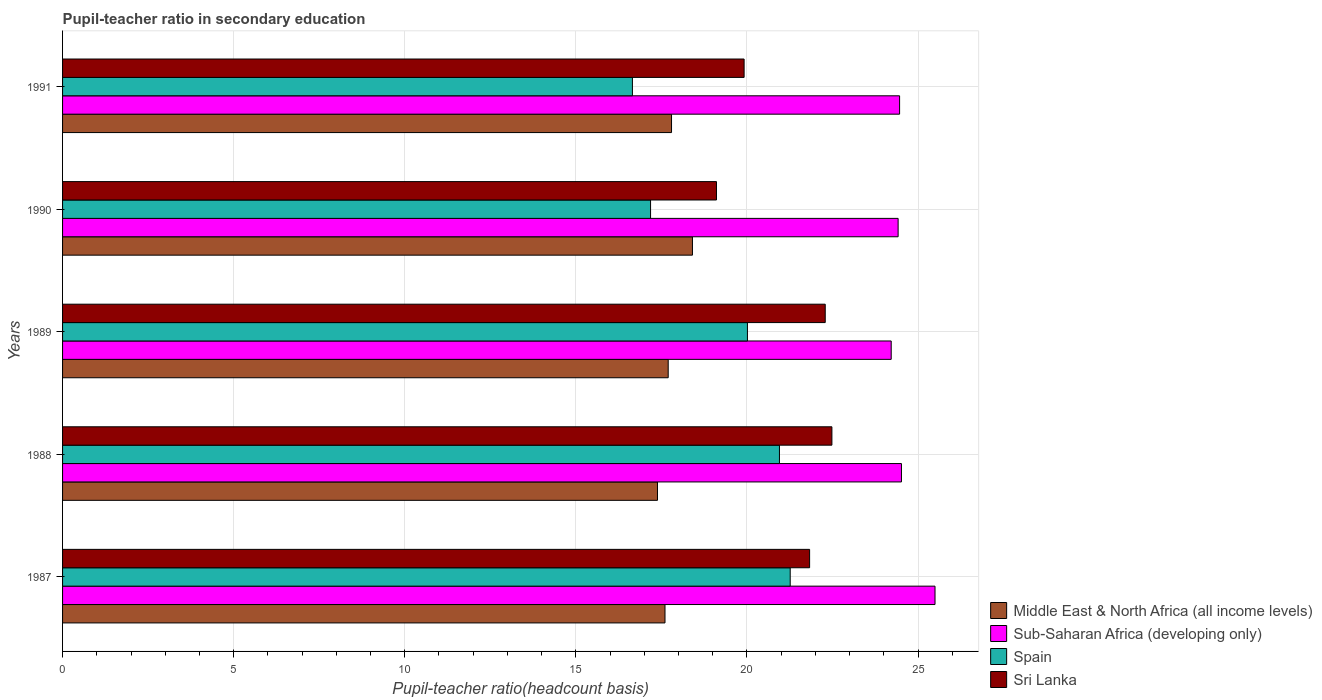How many bars are there on the 3rd tick from the bottom?
Offer a very short reply. 4. In how many cases, is the number of bars for a given year not equal to the number of legend labels?
Provide a short and direct response. 0. What is the pupil-teacher ratio in secondary education in Sri Lanka in 1990?
Make the answer very short. 19.11. Across all years, what is the maximum pupil-teacher ratio in secondary education in Middle East & North Africa (all income levels)?
Keep it short and to the point. 18.41. Across all years, what is the minimum pupil-teacher ratio in secondary education in Sub-Saharan Africa (developing only)?
Give a very brief answer. 24.22. What is the total pupil-teacher ratio in secondary education in Sub-Saharan Africa (developing only) in the graph?
Your answer should be very brief. 123.1. What is the difference between the pupil-teacher ratio in secondary education in Sub-Saharan Africa (developing only) in 1987 and that in 1990?
Ensure brevity in your answer.  1.08. What is the difference between the pupil-teacher ratio in secondary education in Sri Lanka in 1990 and the pupil-teacher ratio in secondary education in Spain in 1989?
Provide a short and direct response. -0.9. What is the average pupil-teacher ratio in secondary education in Sub-Saharan Africa (developing only) per year?
Provide a succinct answer. 24.62. In the year 1988, what is the difference between the pupil-teacher ratio in secondary education in Sub-Saharan Africa (developing only) and pupil-teacher ratio in secondary education in Middle East & North Africa (all income levels)?
Keep it short and to the point. 7.13. In how many years, is the pupil-teacher ratio in secondary education in Sub-Saharan Africa (developing only) greater than 8 ?
Ensure brevity in your answer.  5. What is the ratio of the pupil-teacher ratio in secondary education in Sri Lanka in 1990 to that in 1991?
Your answer should be compact. 0.96. Is the difference between the pupil-teacher ratio in secondary education in Sub-Saharan Africa (developing only) in 1987 and 1991 greater than the difference between the pupil-teacher ratio in secondary education in Middle East & North Africa (all income levels) in 1987 and 1991?
Offer a terse response. Yes. What is the difference between the highest and the second highest pupil-teacher ratio in secondary education in Spain?
Provide a succinct answer. 0.31. What is the difference between the highest and the lowest pupil-teacher ratio in secondary education in Spain?
Offer a very short reply. 4.61. Is the sum of the pupil-teacher ratio in secondary education in Middle East & North Africa (all income levels) in 1987 and 1990 greater than the maximum pupil-teacher ratio in secondary education in Sub-Saharan Africa (developing only) across all years?
Give a very brief answer. Yes. Is it the case that in every year, the sum of the pupil-teacher ratio in secondary education in Sri Lanka and pupil-teacher ratio in secondary education in Sub-Saharan Africa (developing only) is greater than the sum of pupil-teacher ratio in secondary education in Spain and pupil-teacher ratio in secondary education in Middle East & North Africa (all income levels)?
Provide a succinct answer. Yes. What does the 2nd bar from the top in 1988 represents?
Ensure brevity in your answer.  Spain. What does the 3rd bar from the bottom in 1991 represents?
Your answer should be compact. Spain. Is it the case that in every year, the sum of the pupil-teacher ratio in secondary education in Sri Lanka and pupil-teacher ratio in secondary education in Middle East & North Africa (all income levels) is greater than the pupil-teacher ratio in secondary education in Sub-Saharan Africa (developing only)?
Your answer should be very brief. Yes. How many bars are there?
Keep it short and to the point. 20. Are all the bars in the graph horizontal?
Provide a succinct answer. Yes. How many years are there in the graph?
Your response must be concise. 5. What is the difference between two consecutive major ticks on the X-axis?
Provide a succinct answer. 5. Where does the legend appear in the graph?
Your answer should be compact. Bottom right. How many legend labels are there?
Provide a succinct answer. 4. How are the legend labels stacked?
Keep it short and to the point. Vertical. What is the title of the graph?
Your answer should be compact. Pupil-teacher ratio in secondary education. What is the label or title of the X-axis?
Make the answer very short. Pupil-teacher ratio(headcount basis). What is the Pupil-teacher ratio(headcount basis) in Middle East & North Africa (all income levels) in 1987?
Offer a terse response. 17.61. What is the Pupil-teacher ratio(headcount basis) of Sub-Saharan Africa (developing only) in 1987?
Give a very brief answer. 25.5. What is the Pupil-teacher ratio(headcount basis) of Spain in 1987?
Your answer should be very brief. 21.26. What is the Pupil-teacher ratio(headcount basis) in Sri Lanka in 1987?
Offer a terse response. 21.83. What is the Pupil-teacher ratio(headcount basis) of Middle East & North Africa (all income levels) in 1988?
Your response must be concise. 17.39. What is the Pupil-teacher ratio(headcount basis) in Sub-Saharan Africa (developing only) in 1988?
Keep it short and to the point. 24.51. What is the Pupil-teacher ratio(headcount basis) of Spain in 1988?
Offer a terse response. 20.95. What is the Pupil-teacher ratio(headcount basis) in Sri Lanka in 1988?
Your answer should be compact. 22.48. What is the Pupil-teacher ratio(headcount basis) in Middle East & North Africa (all income levels) in 1989?
Offer a very short reply. 17.7. What is the Pupil-teacher ratio(headcount basis) in Sub-Saharan Africa (developing only) in 1989?
Ensure brevity in your answer.  24.22. What is the Pupil-teacher ratio(headcount basis) of Spain in 1989?
Your response must be concise. 20.01. What is the Pupil-teacher ratio(headcount basis) of Sri Lanka in 1989?
Provide a succinct answer. 22.29. What is the Pupil-teacher ratio(headcount basis) of Middle East & North Africa (all income levels) in 1990?
Keep it short and to the point. 18.41. What is the Pupil-teacher ratio(headcount basis) of Sub-Saharan Africa (developing only) in 1990?
Offer a terse response. 24.42. What is the Pupil-teacher ratio(headcount basis) in Spain in 1990?
Your response must be concise. 17.18. What is the Pupil-teacher ratio(headcount basis) of Sri Lanka in 1990?
Give a very brief answer. 19.11. What is the Pupil-teacher ratio(headcount basis) in Middle East & North Africa (all income levels) in 1991?
Give a very brief answer. 17.8. What is the Pupil-teacher ratio(headcount basis) of Sub-Saharan Africa (developing only) in 1991?
Make the answer very short. 24.46. What is the Pupil-teacher ratio(headcount basis) in Spain in 1991?
Your answer should be compact. 16.65. What is the Pupil-teacher ratio(headcount basis) of Sri Lanka in 1991?
Your response must be concise. 19.92. Across all years, what is the maximum Pupil-teacher ratio(headcount basis) in Middle East & North Africa (all income levels)?
Offer a terse response. 18.41. Across all years, what is the maximum Pupil-teacher ratio(headcount basis) in Sub-Saharan Africa (developing only)?
Offer a terse response. 25.5. Across all years, what is the maximum Pupil-teacher ratio(headcount basis) of Spain?
Make the answer very short. 21.26. Across all years, what is the maximum Pupil-teacher ratio(headcount basis) in Sri Lanka?
Keep it short and to the point. 22.48. Across all years, what is the minimum Pupil-teacher ratio(headcount basis) in Middle East & North Africa (all income levels)?
Provide a succinct answer. 17.39. Across all years, what is the minimum Pupil-teacher ratio(headcount basis) of Sub-Saharan Africa (developing only)?
Offer a terse response. 24.22. Across all years, what is the minimum Pupil-teacher ratio(headcount basis) of Spain?
Ensure brevity in your answer.  16.65. Across all years, what is the minimum Pupil-teacher ratio(headcount basis) in Sri Lanka?
Your answer should be very brief. 19.11. What is the total Pupil-teacher ratio(headcount basis) in Middle East & North Africa (all income levels) in the graph?
Your response must be concise. 88.89. What is the total Pupil-teacher ratio(headcount basis) of Sub-Saharan Africa (developing only) in the graph?
Offer a very short reply. 123.1. What is the total Pupil-teacher ratio(headcount basis) in Spain in the graph?
Ensure brevity in your answer.  96.06. What is the total Pupil-teacher ratio(headcount basis) in Sri Lanka in the graph?
Ensure brevity in your answer.  105.63. What is the difference between the Pupil-teacher ratio(headcount basis) in Middle East & North Africa (all income levels) in 1987 and that in 1988?
Ensure brevity in your answer.  0.22. What is the difference between the Pupil-teacher ratio(headcount basis) of Sub-Saharan Africa (developing only) in 1987 and that in 1988?
Make the answer very short. 0.98. What is the difference between the Pupil-teacher ratio(headcount basis) in Spain in 1987 and that in 1988?
Ensure brevity in your answer.  0.31. What is the difference between the Pupil-teacher ratio(headcount basis) in Sri Lanka in 1987 and that in 1988?
Offer a terse response. -0.65. What is the difference between the Pupil-teacher ratio(headcount basis) of Middle East & North Africa (all income levels) in 1987 and that in 1989?
Keep it short and to the point. -0.09. What is the difference between the Pupil-teacher ratio(headcount basis) in Sub-Saharan Africa (developing only) in 1987 and that in 1989?
Your answer should be compact. 1.28. What is the difference between the Pupil-teacher ratio(headcount basis) in Spain in 1987 and that in 1989?
Give a very brief answer. 1.25. What is the difference between the Pupil-teacher ratio(headcount basis) of Sri Lanka in 1987 and that in 1989?
Provide a short and direct response. -0.46. What is the difference between the Pupil-teacher ratio(headcount basis) of Middle East & North Africa (all income levels) in 1987 and that in 1990?
Offer a very short reply. -0.8. What is the difference between the Pupil-teacher ratio(headcount basis) of Sub-Saharan Africa (developing only) in 1987 and that in 1990?
Ensure brevity in your answer.  1.08. What is the difference between the Pupil-teacher ratio(headcount basis) in Spain in 1987 and that in 1990?
Provide a succinct answer. 4.08. What is the difference between the Pupil-teacher ratio(headcount basis) in Sri Lanka in 1987 and that in 1990?
Make the answer very short. 2.72. What is the difference between the Pupil-teacher ratio(headcount basis) of Middle East & North Africa (all income levels) in 1987 and that in 1991?
Your answer should be compact. -0.19. What is the difference between the Pupil-teacher ratio(headcount basis) in Sub-Saharan Africa (developing only) in 1987 and that in 1991?
Offer a terse response. 1.03. What is the difference between the Pupil-teacher ratio(headcount basis) of Spain in 1987 and that in 1991?
Make the answer very short. 4.61. What is the difference between the Pupil-teacher ratio(headcount basis) in Sri Lanka in 1987 and that in 1991?
Ensure brevity in your answer.  1.91. What is the difference between the Pupil-teacher ratio(headcount basis) in Middle East & North Africa (all income levels) in 1988 and that in 1989?
Give a very brief answer. -0.31. What is the difference between the Pupil-teacher ratio(headcount basis) of Sub-Saharan Africa (developing only) in 1988 and that in 1989?
Offer a terse response. 0.3. What is the difference between the Pupil-teacher ratio(headcount basis) in Spain in 1988 and that in 1989?
Your answer should be very brief. 0.94. What is the difference between the Pupil-teacher ratio(headcount basis) of Sri Lanka in 1988 and that in 1989?
Your answer should be very brief. 0.2. What is the difference between the Pupil-teacher ratio(headcount basis) of Middle East & North Africa (all income levels) in 1988 and that in 1990?
Keep it short and to the point. -1.02. What is the difference between the Pupil-teacher ratio(headcount basis) of Sub-Saharan Africa (developing only) in 1988 and that in 1990?
Give a very brief answer. 0.1. What is the difference between the Pupil-teacher ratio(headcount basis) in Spain in 1988 and that in 1990?
Offer a terse response. 3.77. What is the difference between the Pupil-teacher ratio(headcount basis) in Sri Lanka in 1988 and that in 1990?
Provide a succinct answer. 3.37. What is the difference between the Pupil-teacher ratio(headcount basis) of Middle East & North Africa (all income levels) in 1988 and that in 1991?
Keep it short and to the point. -0.41. What is the difference between the Pupil-teacher ratio(headcount basis) of Sub-Saharan Africa (developing only) in 1988 and that in 1991?
Keep it short and to the point. 0.05. What is the difference between the Pupil-teacher ratio(headcount basis) in Spain in 1988 and that in 1991?
Make the answer very short. 4.3. What is the difference between the Pupil-teacher ratio(headcount basis) of Sri Lanka in 1988 and that in 1991?
Provide a short and direct response. 2.57. What is the difference between the Pupil-teacher ratio(headcount basis) of Middle East & North Africa (all income levels) in 1989 and that in 1990?
Ensure brevity in your answer.  -0.71. What is the difference between the Pupil-teacher ratio(headcount basis) of Sub-Saharan Africa (developing only) in 1989 and that in 1990?
Ensure brevity in your answer.  -0.2. What is the difference between the Pupil-teacher ratio(headcount basis) in Spain in 1989 and that in 1990?
Provide a succinct answer. 2.83. What is the difference between the Pupil-teacher ratio(headcount basis) in Sri Lanka in 1989 and that in 1990?
Keep it short and to the point. 3.18. What is the difference between the Pupil-teacher ratio(headcount basis) in Middle East & North Africa (all income levels) in 1989 and that in 1991?
Keep it short and to the point. -0.1. What is the difference between the Pupil-teacher ratio(headcount basis) in Sub-Saharan Africa (developing only) in 1989 and that in 1991?
Provide a succinct answer. -0.25. What is the difference between the Pupil-teacher ratio(headcount basis) of Spain in 1989 and that in 1991?
Give a very brief answer. 3.36. What is the difference between the Pupil-teacher ratio(headcount basis) of Sri Lanka in 1989 and that in 1991?
Ensure brevity in your answer.  2.37. What is the difference between the Pupil-teacher ratio(headcount basis) of Middle East & North Africa (all income levels) in 1990 and that in 1991?
Provide a short and direct response. 0.61. What is the difference between the Pupil-teacher ratio(headcount basis) of Sub-Saharan Africa (developing only) in 1990 and that in 1991?
Keep it short and to the point. -0.04. What is the difference between the Pupil-teacher ratio(headcount basis) in Spain in 1990 and that in 1991?
Provide a short and direct response. 0.53. What is the difference between the Pupil-teacher ratio(headcount basis) in Sri Lanka in 1990 and that in 1991?
Your answer should be compact. -0.81. What is the difference between the Pupil-teacher ratio(headcount basis) in Middle East & North Africa (all income levels) in 1987 and the Pupil-teacher ratio(headcount basis) in Sub-Saharan Africa (developing only) in 1988?
Provide a short and direct response. -6.91. What is the difference between the Pupil-teacher ratio(headcount basis) of Middle East & North Africa (all income levels) in 1987 and the Pupil-teacher ratio(headcount basis) of Spain in 1988?
Keep it short and to the point. -3.34. What is the difference between the Pupil-teacher ratio(headcount basis) in Middle East & North Africa (all income levels) in 1987 and the Pupil-teacher ratio(headcount basis) in Sri Lanka in 1988?
Offer a very short reply. -4.88. What is the difference between the Pupil-teacher ratio(headcount basis) of Sub-Saharan Africa (developing only) in 1987 and the Pupil-teacher ratio(headcount basis) of Spain in 1988?
Provide a short and direct response. 4.55. What is the difference between the Pupil-teacher ratio(headcount basis) in Sub-Saharan Africa (developing only) in 1987 and the Pupil-teacher ratio(headcount basis) in Sri Lanka in 1988?
Provide a succinct answer. 3.01. What is the difference between the Pupil-teacher ratio(headcount basis) in Spain in 1987 and the Pupil-teacher ratio(headcount basis) in Sri Lanka in 1988?
Provide a succinct answer. -1.22. What is the difference between the Pupil-teacher ratio(headcount basis) in Middle East & North Africa (all income levels) in 1987 and the Pupil-teacher ratio(headcount basis) in Sub-Saharan Africa (developing only) in 1989?
Keep it short and to the point. -6.61. What is the difference between the Pupil-teacher ratio(headcount basis) of Middle East & North Africa (all income levels) in 1987 and the Pupil-teacher ratio(headcount basis) of Spain in 1989?
Your answer should be very brief. -2.41. What is the difference between the Pupil-teacher ratio(headcount basis) in Middle East & North Africa (all income levels) in 1987 and the Pupil-teacher ratio(headcount basis) in Sri Lanka in 1989?
Provide a short and direct response. -4.68. What is the difference between the Pupil-teacher ratio(headcount basis) in Sub-Saharan Africa (developing only) in 1987 and the Pupil-teacher ratio(headcount basis) in Spain in 1989?
Provide a short and direct response. 5.48. What is the difference between the Pupil-teacher ratio(headcount basis) in Sub-Saharan Africa (developing only) in 1987 and the Pupil-teacher ratio(headcount basis) in Sri Lanka in 1989?
Your answer should be very brief. 3.21. What is the difference between the Pupil-teacher ratio(headcount basis) of Spain in 1987 and the Pupil-teacher ratio(headcount basis) of Sri Lanka in 1989?
Your answer should be very brief. -1.02. What is the difference between the Pupil-teacher ratio(headcount basis) in Middle East & North Africa (all income levels) in 1987 and the Pupil-teacher ratio(headcount basis) in Sub-Saharan Africa (developing only) in 1990?
Provide a short and direct response. -6.81. What is the difference between the Pupil-teacher ratio(headcount basis) of Middle East & North Africa (all income levels) in 1987 and the Pupil-teacher ratio(headcount basis) of Spain in 1990?
Provide a succinct answer. 0.42. What is the difference between the Pupil-teacher ratio(headcount basis) in Middle East & North Africa (all income levels) in 1987 and the Pupil-teacher ratio(headcount basis) in Sri Lanka in 1990?
Provide a short and direct response. -1.5. What is the difference between the Pupil-teacher ratio(headcount basis) of Sub-Saharan Africa (developing only) in 1987 and the Pupil-teacher ratio(headcount basis) of Spain in 1990?
Keep it short and to the point. 8.31. What is the difference between the Pupil-teacher ratio(headcount basis) of Sub-Saharan Africa (developing only) in 1987 and the Pupil-teacher ratio(headcount basis) of Sri Lanka in 1990?
Your response must be concise. 6.39. What is the difference between the Pupil-teacher ratio(headcount basis) in Spain in 1987 and the Pupil-teacher ratio(headcount basis) in Sri Lanka in 1990?
Your response must be concise. 2.15. What is the difference between the Pupil-teacher ratio(headcount basis) in Middle East & North Africa (all income levels) in 1987 and the Pupil-teacher ratio(headcount basis) in Sub-Saharan Africa (developing only) in 1991?
Your response must be concise. -6.86. What is the difference between the Pupil-teacher ratio(headcount basis) in Middle East & North Africa (all income levels) in 1987 and the Pupil-teacher ratio(headcount basis) in Spain in 1991?
Your answer should be compact. 0.95. What is the difference between the Pupil-teacher ratio(headcount basis) in Middle East & North Africa (all income levels) in 1987 and the Pupil-teacher ratio(headcount basis) in Sri Lanka in 1991?
Your response must be concise. -2.31. What is the difference between the Pupil-teacher ratio(headcount basis) in Sub-Saharan Africa (developing only) in 1987 and the Pupil-teacher ratio(headcount basis) in Spain in 1991?
Your answer should be very brief. 8.84. What is the difference between the Pupil-teacher ratio(headcount basis) in Sub-Saharan Africa (developing only) in 1987 and the Pupil-teacher ratio(headcount basis) in Sri Lanka in 1991?
Your response must be concise. 5.58. What is the difference between the Pupil-teacher ratio(headcount basis) in Spain in 1987 and the Pupil-teacher ratio(headcount basis) in Sri Lanka in 1991?
Ensure brevity in your answer.  1.35. What is the difference between the Pupil-teacher ratio(headcount basis) in Middle East & North Africa (all income levels) in 1988 and the Pupil-teacher ratio(headcount basis) in Sub-Saharan Africa (developing only) in 1989?
Your response must be concise. -6.83. What is the difference between the Pupil-teacher ratio(headcount basis) in Middle East & North Africa (all income levels) in 1988 and the Pupil-teacher ratio(headcount basis) in Spain in 1989?
Ensure brevity in your answer.  -2.63. What is the difference between the Pupil-teacher ratio(headcount basis) of Middle East & North Africa (all income levels) in 1988 and the Pupil-teacher ratio(headcount basis) of Sri Lanka in 1989?
Offer a terse response. -4.9. What is the difference between the Pupil-teacher ratio(headcount basis) in Sub-Saharan Africa (developing only) in 1988 and the Pupil-teacher ratio(headcount basis) in Spain in 1989?
Your response must be concise. 4.5. What is the difference between the Pupil-teacher ratio(headcount basis) of Sub-Saharan Africa (developing only) in 1988 and the Pupil-teacher ratio(headcount basis) of Sri Lanka in 1989?
Offer a very short reply. 2.23. What is the difference between the Pupil-teacher ratio(headcount basis) in Spain in 1988 and the Pupil-teacher ratio(headcount basis) in Sri Lanka in 1989?
Ensure brevity in your answer.  -1.34. What is the difference between the Pupil-teacher ratio(headcount basis) in Middle East & North Africa (all income levels) in 1988 and the Pupil-teacher ratio(headcount basis) in Sub-Saharan Africa (developing only) in 1990?
Your response must be concise. -7.03. What is the difference between the Pupil-teacher ratio(headcount basis) in Middle East & North Africa (all income levels) in 1988 and the Pupil-teacher ratio(headcount basis) in Spain in 1990?
Your answer should be compact. 0.2. What is the difference between the Pupil-teacher ratio(headcount basis) in Middle East & North Africa (all income levels) in 1988 and the Pupil-teacher ratio(headcount basis) in Sri Lanka in 1990?
Keep it short and to the point. -1.72. What is the difference between the Pupil-teacher ratio(headcount basis) in Sub-Saharan Africa (developing only) in 1988 and the Pupil-teacher ratio(headcount basis) in Spain in 1990?
Provide a short and direct response. 7.33. What is the difference between the Pupil-teacher ratio(headcount basis) of Sub-Saharan Africa (developing only) in 1988 and the Pupil-teacher ratio(headcount basis) of Sri Lanka in 1990?
Offer a terse response. 5.41. What is the difference between the Pupil-teacher ratio(headcount basis) of Spain in 1988 and the Pupil-teacher ratio(headcount basis) of Sri Lanka in 1990?
Your response must be concise. 1.84. What is the difference between the Pupil-teacher ratio(headcount basis) in Middle East & North Africa (all income levels) in 1988 and the Pupil-teacher ratio(headcount basis) in Sub-Saharan Africa (developing only) in 1991?
Provide a short and direct response. -7.08. What is the difference between the Pupil-teacher ratio(headcount basis) of Middle East & North Africa (all income levels) in 1988 and the Pupil-teacher ratio(headcount basis) of Spain in 1991?
Provide a succinct answer. 0.73. What is the difference between the Pupil-teacher ratio(headcount basis) of Middle East & North Africa (all income levels) in 1988 and the Pupil-teacher ratio(headcount basis) of Sri Lanka in 1991?
Ensure brevity in your answer.  -2.53. What is the difference between the Pupil-teacher ratio(headcount basis) in Sub-Saharan Africa (developing only) in 1988 and the Pupil-teacher ratio(headcount basis) in Spain in 1991?
Provide a succinct answer. 7.86. What is the difference between the Pupil-teacher ratio(headcount basis) of Sub-Saharan Africa (developing only) in 1988 and the Pupil-teacher ratio(headcount basis) of Sri Lanka in 1991?
Provide a short and direct response. 4.6. What is the difference between the Pupil-teacher ratio(headcount basis) of Spain in 1988 and the Pupil-teacher ratio(headcount basis) of Sri Lanka in 1991?
Your answer should be very brief. 1.03. What is the difference between the Pupil-teacher ratio(headcount basis) in Middle East & North Africa (all income levels) in 1989 and the Pupil-teacher ratio(headcount basis) in Sub-Saharan Africa (developing only) in 1990?
Ensure brevity in your answer.  -6.72. What is the difference between the Pupil-teacher ratio(headcount basis) in Middle East & North Africa (all income levels) in 1989 and the Pupil-teacher ratio(headcount basis) in Spain in 1990?
Make the answer very short. 0.52. What is the difference between the Pupil-teacher ratio(headcount basis) in Middle East & North Africa (all income levels) in 1989 and the Pupil-teacher ratio(headcount basis) in Sri Lanka in 1990?
Your answer should be compact. -1.41. What is the difference between the Pupil-teacher ratio(headcount basis) in Sub-Saharan Africa (developing only) in 1989 and the Pupil-teacher ratio(headcount basis) in Spain in 1990?
Give a very brief answer. 7.03. What is the difference between the Pupil-teacher ratio(headcount basis) in Sub-Saharan Africa (developing only) in 1989 and the Pupil-teacher ratio(headcount basis) in Sri Lanka in 1990?
Make the answer very short. 5.11. What is the difference between the Pupil-teacher ratio(headcount basis) in Spain in 1989 and the Pupil-teacher ratio(headcount basis) in Sri Lanka in 1990?
Make the answer very short. 0.9. What is the difference between the Pupil-teacher ratio(headcount basis) of Middle East & North Africa (all income levels) in 1989 and the Pupil-teacher ratio(headcount basis) of Sub-Saharan Africa (developing only) in 1991?
Offer a very short reply. -6.76. What is the difference between the Pupil-teacher ratio(headcount basis) of Middle East & North Africa (all income levels) in 1989 and the Pupil-teacher ratio(headcount basis) of Spain in 1991?
Make the answer very short. 1.05. What is the difference between the Pupil-teacher ratio(headcount basis) of Middle East & North Africa (all income levels) in 1989 and the Pupil-teacher ratio(headcount basis) of Sri Lanka in 1991?
Ensure brevity in your answer.  -2.22. What is the difference between the Pupil-teacher ratio(headcount basis) of Sub-Saharan Africa (developing only) in 1989 and the Pupil-teacher ratio(headcount basis) of Spain in 1991?
Ensure brevity in your answer.  7.56. What is the difference between the Pupil-teacher ratio(headcount basis) in Sub-Saharan Africa (developing only) in 1989 and the Pupil-teacher ratio(headcount basis) in Sri Lanka in 1991?
Provide a succinct answer. 4.3. What is the difference between the Pupil-teacher ratio(headcount basis) in Spain in 1989 and the Pupil-teacher ratio(headcount basis) in Sri Lanka in 1991?
Your response must be concise. 0.1. What is the difference between the Pupil-teacher ratio(headcount basis) in Middle East & North Africa (all income levels) in 1990 and the Pupil-teacher ratio(headcount basis) in Sub-Saharan Africa (developing only) in 1991?
Your answer should be very brief. -6.05. What is the difference between the Pupil-teacher ratio(headcount basis) of Middle East & North Africa (all income levels) in 1990 and the Pupil-teacher ratio(headcount basis) of Spain in 1991?
Your answer should be very brief. 1.75. What is the difference between the Pupil-teacher ratio(headcount basis) of Middle East & North Africa (all income levels) in 1990 and the Pupil-teacher ratio(headcount basis) of Sri Lanka in 1991?
Provide a succinct answer. -1.51. What is the difference between the Pupil-teacher ratio(headcount basis) of Sub-Saharan Africa (developing only) in 1990 and the Pupil-teacher ratio(headcount basis) of Spain in 1991?
Offer a terse response. 7.76. What is the difference between the Pupil-teacher ratio(headcount basis) in Sub-Saharan Africa (developing only) in 1990 and the Pupil-teacher ratio(headcount basis) in Sri Lanka in 1991?
Make the answer very short. 4.5. What is the difference between the Pupil-teacher ratio(headcount basis) of Spain in 1990 and the Pupil-teacher ratio(headcount basis) of Sri Lanka in 1991?
Offer a terse response. -2.73. What is the average Pupil-teacher ratio(headcount basis) in Middle East & North Africa (all income levels) per year?
Provide a short and direct response. 17.78. What is the average Pupil-teacher ratio(headcount basis) of Sub-Saharan Africa (developing only) per year?
Offer a very short reply. 24.62. What is the average Pupil-teacher ratio(headcount basis) in Spain per year?
Make the answer very short. 19.21. What is the average Pupil-teacher ratio(headcount basis) in Sri Lanka per year?
Provide a short and direct response. 21.13. In the year 1987, what is the difference between the Pupil-teacher ratio(headcount basis) of Middle East & North Africa (all income levels) and Pupil-teacher ratio(headcount basis) of Sub-Saharan Africa (developing only)?
Your answer should be very brief. -7.89. In the year 1987, what is the difference between the Pupil-teacher ratio(headcount basis) of Middle East & North Africa (all income levels) and Pupil-teacher ratio(headcount basis) of Spain?
Keep it short and to the point. -3.66. In the year 1987, what is the difference between the Pupil-teacher ratio(headcount basis) in Middle East & North Africa (all income levels) and Pupil-teacher ratio(headcount basis) in Sri Lanka?
Make the answer very short. -4.23. In the year 1987, what is the difference between the Pupil-teacher ratio(headcount basis) in Sub-Saharan Africa (developing only) and Pupil-teacher ratio(headcount basis) in Spain?
Keep it short and to the point. 4.23. In the year 1987, what is the difference between the Pupil-teacher ratio(headcount basis) of Sub-Saharan Africa (developing only) and Pupil-teacher ratio(headcount basis) of Sri Lanka?
Your answer should be very brief. 3.66. In the year 1987, what is the difference between the Pupil-teacher ratio(headcount basis) of Spain and Pupil-teacher ratio(headcount basis) of Sri Lanka?
Your answer should be compact. -0.57. In the year 1988, what is the difference between the Pupil-teacher ratio(headcount basis) in Middle East & North Africa (all income levels) and Pupil-teacher ratio(headcount basis) in Sub-Saharan Africa (developing only)?
Give a very brief answer. -7.13. In the year 1988, what is the difference between the Pupil-teacher ratio(headcount basis) in Middle East & North Africa (all income levels) and Pupil-teacher ratio(headcount basis) in Spain?
Your answer should be very brief. -3.56. In the year 1988, what is the difference between the Pupil-teacher ratio(headcount basis) in Middle East & North Africa (all income levels) and Pupil-teacher ratio(headcount basis) in Sri Lanka?
Give a very brief answer. -5.1. In the year 1988, what is the difference between the Pupil-teacher ratio(headcount basis) in Sub-Saharan Africa (developing only) and Pupil-teacher ratio(headcount basis) in Spain?
Your response must be concise. 3.57. In the year 1988, what is the difference between the Pupil-teacher ratio(headcount basis) of Sub-Saharan Africa (developing only) and Pupil-teacher ratio(headcount basis) of Sri Lanka?
Keep it short and to the point. 2.03. In the year 1988, what is the difference between the Pupil-teacher ratio(headcount basis) of Spain and Pupil-teacher ratio(headcount basis) of Sri Lanka?
Keep it short and to the point. -1.53. In the year 1989, what is the difference between the Pupil-teacher ratio(headcount basis) in Middle East & North Africa (all income levels) and Pupil-teacher ratio(headcount basis) in Sub-Saharan Africa (developing only)?
Your answer should be compact. -6.52. In the year 1989, what is the difference between the Pupil-teacher ratio(headcount basis) in Middle East & North Africa (all income levels) and Pupil-teacher ratio(headcount basis) in Spain?
Keep it short and to the point. -2.32. In the year 1989, what is the difference between the Pupil-teacher ratio(headcount basis) in Middle East & North Africa (all income levels) and Pupil-teacher ratio(headcount basis) in Sri Lanka?
Offer a very short reply. -4.59. In the year 1989, what is the difference between the Pupil-teacher ratio(headcount basis) of Sub-Saharan Africa (developing only) and Pupil-teacher ratio(headcount basis) of Spain?
Provide a succinct answer. 4.2. In the year 1989, what is the difference between the Pupil-teacher ratio(headcount basis) of Sub-Saharan Africa (developing only) and Pupil-teacher ratio(headcount basis) of Sri Lanka?
Provide a succinct answer. 1.93. In the year 1989, what is the difference between the Pupil-teacher ratio(headcount basis) of Spain and Pupil-teacher ratio(headcount basis) of Sri Lanka?
Offer a very short reply. -2.27. In the year 1990, what is the difference between the Pupil-teacher ratio(headcount basis) of Middle East & North Africa (all income levels) and Pupil-teacher ratio(headcount basis) of Sub-Saharan Africa (developing only)?
Offer a very short reply. -6.01. In the year 1990, what is the difference between the Pupil-teacher ratio(headcount basis) in Middle East & North Africa (all income levels) and Pupil-teacher ratio(headcount basis) in Spain?
Provide a succinct answer. 1.22. In the year 1990, what is the difference between the Pupil-teacher ratio(headcount basis) in Middle East & North Africa (all income levels) and Pupil-teacher ratio(headcount basis) in Sri Lanka?
Offer a terse response. -0.7. In the year 1990, what is the difference between the Pupil-teacher ratio(headcount basis) of Sub-Saharan Africa (developing only) and Pupil-teacher ratio(headcount basis) of Spain?
Your answer should be compact. 7.23. In the year 1990, what is the difference between the Pupil-teacher ratio(headcount basis) in Sub-Saharan Africa (developing only) and Pupil-teacher ratio(headcount basis) in Sri Lanka?
Keep it short and to the point. 5.31. In the year 1990, what is the difference between the Pupil-teacher ratio(headcount basis) in Spain and Pupil-teacher ratio(headcount basis) in Sri Lanka?
Your response must be concise. -1.93. In the year 1991, what is the difference between the Pupil-teacher ratio(headcount basis) of Middle East & North Africa (all income levels) and Pupil-teacher ratio(headcount basis) of Sub-Saharan Africa (developing only)?
Your response must be concise. -6.66. In the year 1991, what is the difference between the Pupil-teacher ratio(headcount basis) of Middle East & North Africa (all income levels) and Pupil-teacher ratio(headcount basis) of Spain?
Keep it short and to the point. 1.14. In the year 1991, what is the difference between the Pupil-teacher ratio(headcount basis) in Middle East & North Africa (all income levels) and Pupil-teacher ratio(headcount basis) in Sri Lanka?
Your answer should be compact. -2.12. In the year 1991, what is the difference between the Pupil-teacher ratio(headcount basis) of Sub-Saharan Africa (developing only) and Pupil-teacher ratio(headcount basis) of Spain?
Make the answer very short. 7.81. In the year 1991, what is the difference between the Pupil-teacher ratio(headcount basis) of Sub-Saharan Africa (developing only) and Pupil-teacher ratio(headcount basis) of Sri Lanka?
Your response must be concise. 4.54. In the year 1991, what is the difference between the Pupil-teacher ratio(headcount basis) in Spain and Pupil-teacher ratio(headcount basis) in Sri Lanka?
Ensure brevity in your answer.  -3.26. What is the ratio of the Pupil-teacher ratio(headcount basis) in Middle East & North Africa (all income levels) in 1987 to that in 1988?
Ensure brevity in your answer.  1.01. What is the ratio of the Pupil-teacher ratio(headcount basis) in Spain in 1987 to that in 1988?
Your answer should be very brief. 1.01. What is the ratio of the Pupil-teacher ratio(headcount basis) of Sub-Saharan Africa (developing only) in 1987 to that in 1989?
Ensure brevity in your answer.  1.05. What is the ratio of the Pupil-teacher ratio(headcount basis) in Spain in 1987 to that in 1989?
Your response must be concise. 1.06. What is the ratio of the Pupil-teacher ratio(headcount basis) of Sri Lanka in 1987 to that in 1989?
Make the answer very short. 0.98. What is the ratio of the Pupil-teacher ratio(headcount basis) of Middle East & North Africa (all income levels) in 1987 to that in 1990?
Your response must be concise. 0.96. What is the ratio of the Pupil-teacher ratio(headcount basis) in Sub-Saharan Africa (developing only) in 1987 to that in 1990?
Give a very brief answer. 1.04. What is the ratio of the Pupil-teacher ratio(headcount basis) of Spain in 1987 to that in 1990?
Offer a terse response. 1.24. What is the ratio of the Pupil-teacher ratio(headcount basis) of Sri Lanka in 1987 to that in 1990?
Offer a terse response. 1.14. What is the ratio of the Pupil-teacher ratio(headcount basis) of Middle East & North Africa (all income levels) in 1987 to that in 1991?
Ensure brevity in your answer.  0.99. What is the ratio of the Pupil-teacher ratio(headcount basis) of Sub-Saharan Africa (developing only) in 1987 to that in 1991?
Provide a succinct answer. 1.04. What is the ratio of the Pupil-teacher ratio(headcount basis) in Spain in 1987 to that in 1991?
Your answer should be very brief. 1.28. What is the ratio of the Pupil-teacher ratio(headcount basis) of Sri Lanka in 1987 to that in 1991?
Keep it short and to the point. 1.1. What is the ratio of the Pupil-teacher ratio(headcount basis) in Middle East & North Africa (all income levels) in 1988 to that in 1989?
Ensure brevity in your answer.  0.98. What is the ratio of the Pupil-teacher ratio(headcount basis) of Sub-Saharan Africa (developing only) in 1988 to that in 1989?
Provide a short and direct response. 1.01. What is the ratio of the Pupil-teacher ratio(headcount basis) in Spain in 1988 to that in 1989?
Make the answer very short. 1.05. What is the ratio of the Pupil-teacher ratio(headcount basis) of Sri Lanka in 1988 to that in 1989?
Give a very brief answer. 1.01. What is the ratio of the Pupil-teacher ratio(headcount basis) in Middle East & North Africa (all income levels) in 1988 to that in 1990?
Provide a short and direct response. 0.94. What is the ratio of the Pupil-teacher ratio(headcount basis) in Sub-Saharan Africa (developing only) in 1988 to that in 1990?
Offer a terse response. 1. What is the ratio of the Pupil-teacher ratio(headcount basis) in Spain in 1988 to that in 1990?
Ensure brevity in your answer.  1.22. What is the ratio of the Pupil-teacher ratio(headcount basis) in Sri Lanka in 1988 to that in 1990?
Ensure brevity in your answer.  1.18. What is the ratio of the Pupil-teacher ratio(headcount basis) in Middle East & North Africa (all income levels) in 1988 to that in 1991?
Offer a very short reply. 0.98. What is the ratio of the Pupil-teacher ratio(headcount basis) in Spain in 1988 to that in 1991?
Your response must be concise. 1.26. What is the ratio of the Pupil-teacher ratio(headcount basis) in Sri Lanka in 1988 to that in 1991?
Offer a terse response. 1.13. What is the ratio of the Pupil-teacher ratio(headcount basis) in Middle East & North Africa (all income levels) in 1989 to that in 1990?
Offer a very short reply. 0.96. What is the ratio of the Pupil-teacher ratio(headcount basis) of Sub-Saharan Africa (developing only) in 1989 to that in 1990?
Offer a very short reply. 0.99. What is the ratio of the Pupil-teacher ratio(headcount basis) of Spain in 1989 to that in 1990?
Your response must be concise. 1.16. What is the ratio of the Pupil-teacher ratio(headcount basis) in Sri Lanka in 1989 to that in 1990?
Your answer should be very brief. 1.17. What is the ratio of the Pupil-teacher ratio(headcount basis) in Middle East & North Africa (all income levels) in 1989 to that in 1991?
Keep it short and to the point. 0.99. What is the ratio of the Pupil-teacher ratio(headcount basis) of Spain in 1989 to that in 1991?
Your response must be concise. 1.2. What is the ratio of the Pupil-teacher ratio(headcount basis) of Sri Lanka in 1989 to that in 1991?
Offer a terse response. 1.12. What is the ratio of the Pupil-teacher ratio(headcount basis) of Middle East & North Africa (all income levels) in 1990 to that in 1991?
Your response must be concise. 1.03. What is the ratio of the Pupil-teacher ratio(headcount basis) in Sub-Saharan Africa (developing only) in 1990 to that in 1991?
Give a very brief answer. 1. What is the ratio of the Pupil-teacher ratio(headcount basis) in Spain in 1990 to that in 1991?
Your answer should be compact. 1.03. What is the ratio of the Pupil-teacher ratio(headcount basis) of Sri Lanka in 1990 to that in 1991?
Ensure brevity in your answer.  0.96. What is the difference between the highest and the second highest Pupil-teacher ratio(headcount basis) in Middle East & North Africa (all income levels)?
Your answer should be compact. 0.61. What is the difference between the highest and the second highest Pupil-teacher ratio(headcount basis) of Sub-Saharan Africa (developing only)?
Provide a succinct answer. 0.98. What is the difference between the highest and the second highest Pupil-teacher ratio(headcount basis) of Spain?
Give a very brief answer. 0.31. What is the difference between the highest and the second highest Pupil-teacher ratio(headcount basis) of Sri Lanka?
Offer a terse response. 0.2. What is the difference between the highest and the lowest Pupil-teacher ratio(headcount basis) of Middle East & North Africa (all income levels)?
Offer a terse response. 1.02. What is the difference between the highest and the lowest Pupil-teacher ratio(headcount basis) of Sub-Saharan Africa (developing only)?
Ensure brevity in your answer.  1.28. What is the difference between the highest and the lowest Pupil-teacher ratio(headcount basis) of Spain?
Your answer should be compact. 4.61. What is the difference between the highest and the lowest Pupil-teacher ratio(headcount basis) in Sri Lanka?
Offer a very short reply. 3.37. 